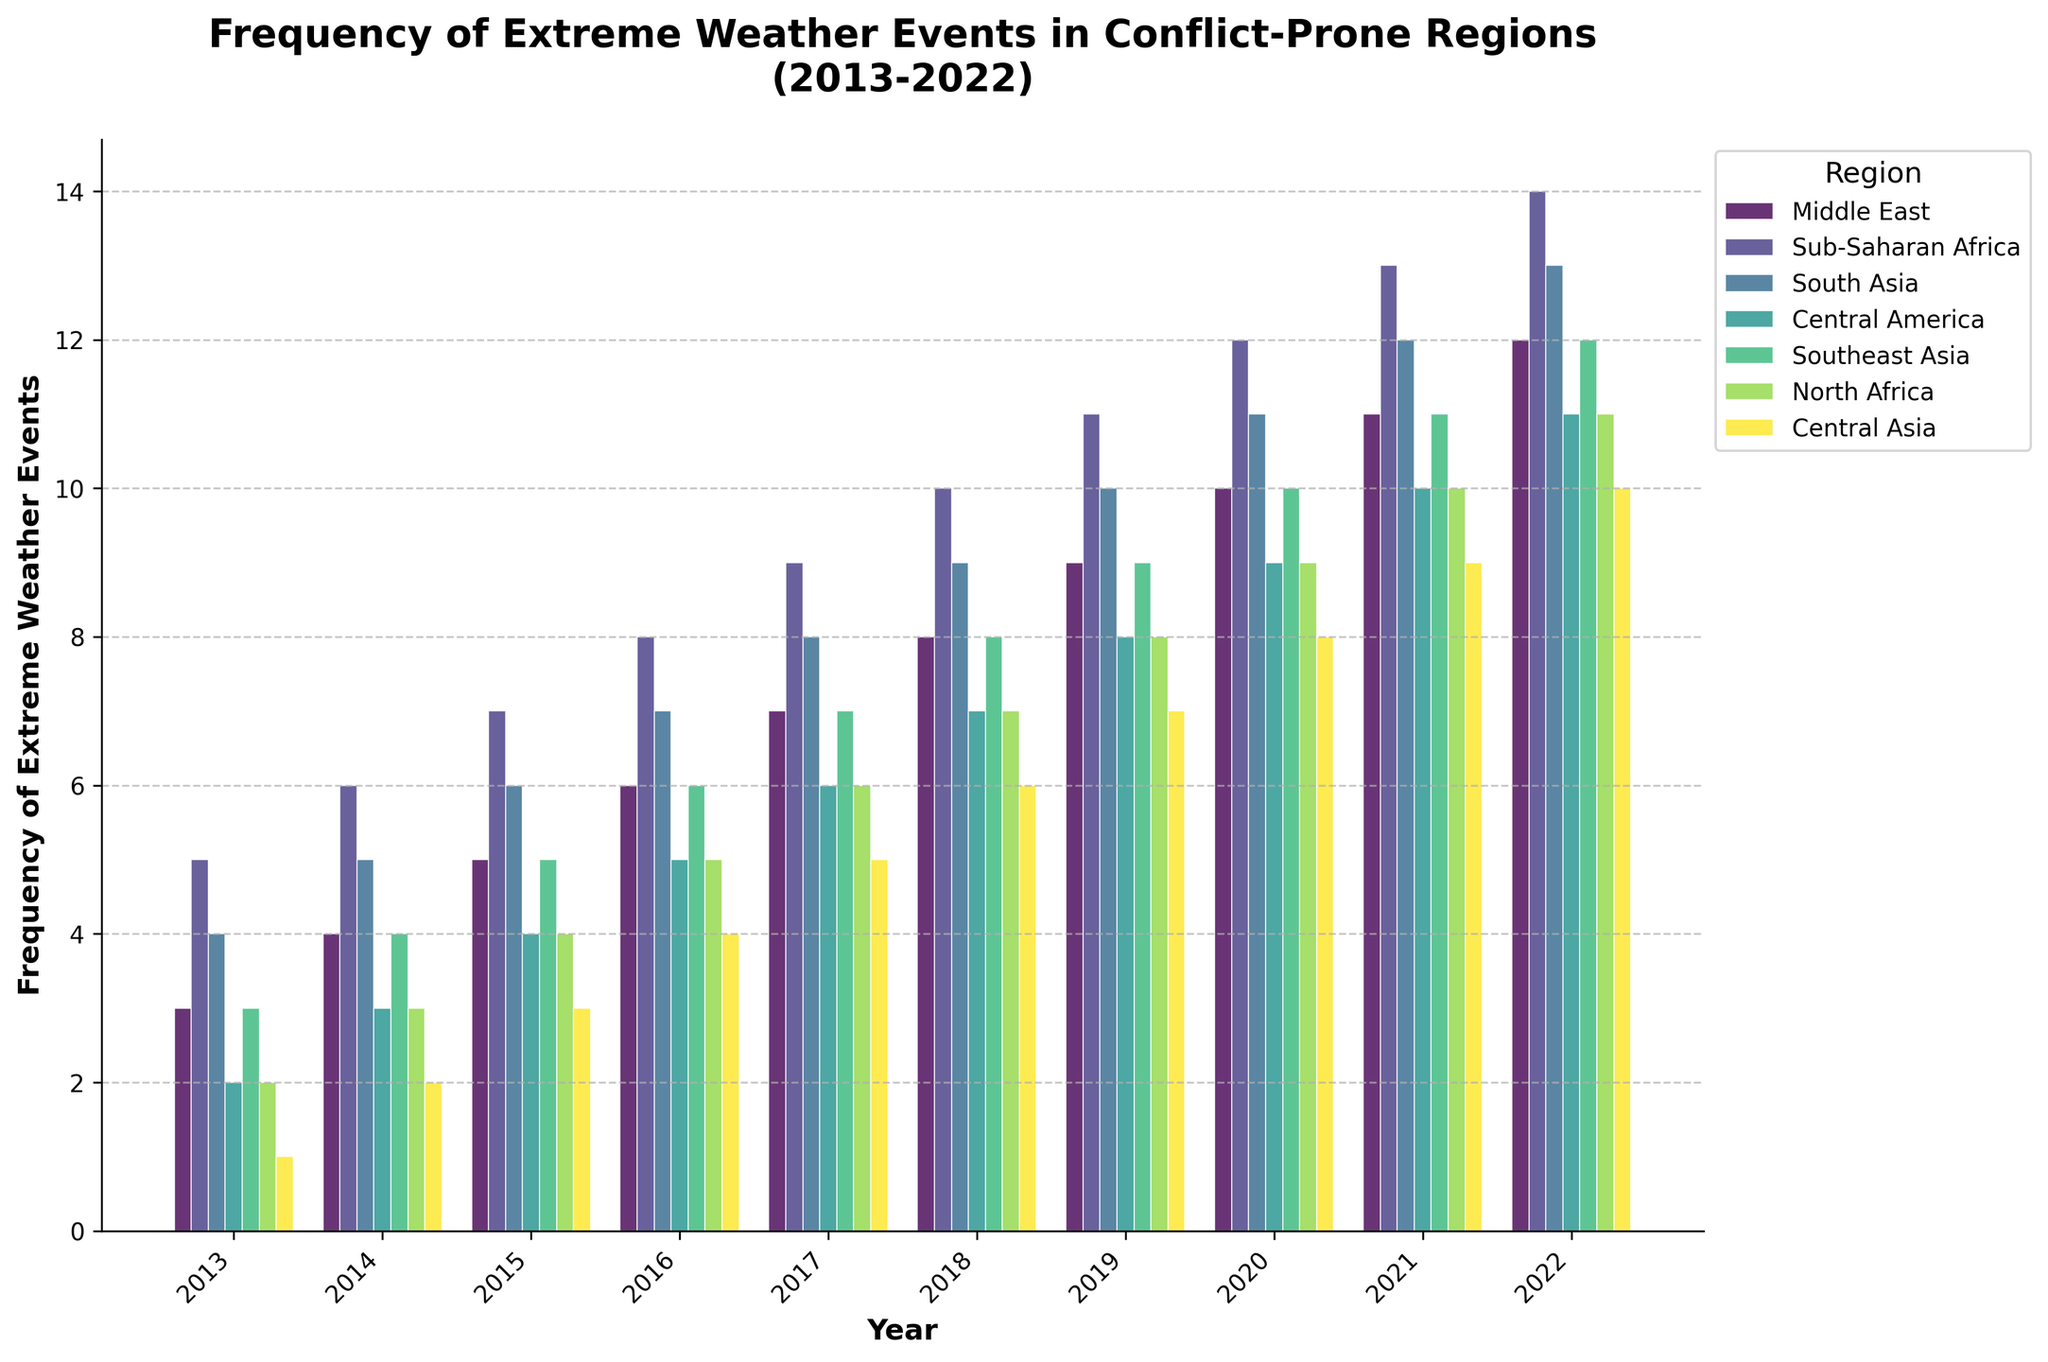Which region experienced the highest frequency of extreme weather events in 2022? From the bar heights in 2022, Sub-Saharan Africa has the tallest bar compared to other regions, indicating the highest frequency of extreme weather events.
Answer: Sub-Saharan Africa Which regions had an equal frequency of extreme weather events in 2014? By comparing the bar heights for each region in 2014, we see that Middle East, Southeast Asia, and North Africa all have equal bar heights, indicating the same frequency of events.
Answer: Middle East, Southeast Asia, North Africa What is the difference in the frequency of extreme weather events between Sub-Saharan Africa and Central Asia in 2020? The bar height for Sub-Saharan Africa in 2020 is 12, and for Central Asia, it is 8. The difference is 12 - 8 = 4.
Answer: 4 Which year saw the largest number of regions experiencing the same frequency of extreme weather events? By scanning the bar heights across years, we note that in 2017, several regions (Middle East, Southeast Asia, North Africa) have the same bar height of 7. This is more than the other years.
Answer: 2017 What is the average frequency of extreme weather events for South Asia over the decade? To calculate the average, sum the frequencies for South Asia from 2013 to 2022: (4 + 5 + 6 + 7 + 8 + 9 + 10 + 11 + 12 + 13) = 85. Divide by 10 years, resulting in an average of 85/10 = 8.5.
Answer: 8.5 Which region shows a consistent increase in the frequency of extreme weather events every year? By observing the trend lines of each region, we see that every year from 2013 to 2022, Sub-Saharan Africa's bar height increases, indicating a consistent uptrend.
Answer: Sub-Saharan Africa In what year did Central America have a lower frequency of extreme weather events than both South Asia and Southeast Asia? By comparing bar heights, in 2016, Central America has a bar height of 5, which is lower than both South Asia (7) and Southeast Asia (6).
Answer: 2016 How many regions experienced exactly 6 extreme weather events in 2016, and which are they? In 2016, by comparing bar heights, regions with a frequency of 6 include Middle East, Southeast Asia, and Central America.
Answer: 3 regions: Middle East, Southeast Asia, Central America What is the total frequency of extreme weather events for North Africa across the decade? Summing the bar heights for North Africa from 2013 to 2022: (2 + 3 + 4 + 5 + 6 + 7 + 8 + 9 + 10 + 11) = 65.
Answer: 65 Which region had a greater increase in frequency from 2013 to 2022, Middle East or Central America, and by how much? The increase for Middle East is 12 (2013: 3 to 2022: 12) and for Central America is 9 (2013: 2 to 2022: 11). The difference is 12 - 9 = 3, so the Middle East had a greater increase.
Answer: Middle East by 3 